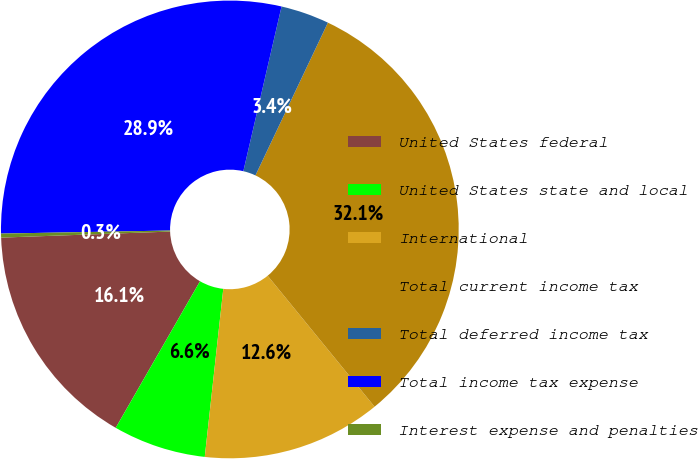<chart> <loc_0><loc_0><loc_500><loc_500><pie_chart><fcel>United States federal<fcel>United States state and local<fcel>International<fcel>Total current income tax<fcel>Total deferred income tax<fcel>Total income tax expense<fcel>Interest expense and penalties<nl><fcel>16.12%<fcel>6.56%<fcel>12.64%<fcel>32.05%<fcel>3.42%<fcel>28.91%<fcel>0.28%<nl></chart> 